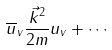Convert formula to latex. <formula><loc_0><loc_0><loc_500><loc_500>\overline { u } _ { v } \frac { \vec { k } ^ { 2 } } { 2 m } u _ { v } + \cdots</formula> 